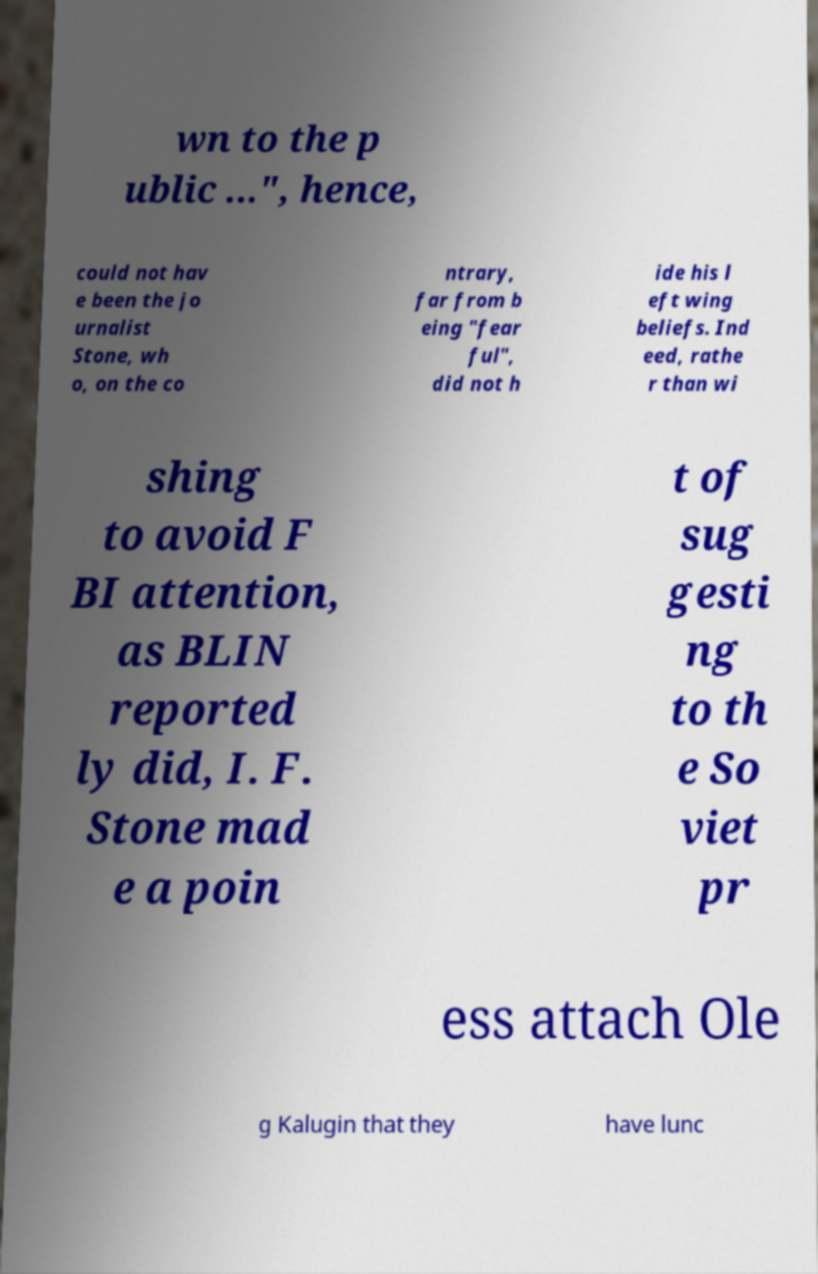There's text embedded in this image that I need extracted. Can you transcribe it verbatim? wn to the p ublic ...", hence, could not hav e been the jo urnalist Stone, wh o, on the co ntrary, far from b eing "fear ful", did not h ide his l eft wing beliefs. Ind eed, rathe r than wi shing to avoid F BI attention, as BLIN reported ly did, I. F. Stone mad e a poin t of sug gesti ng to th e So viet pr ess attach Ole g Kalugin that they have lunc 